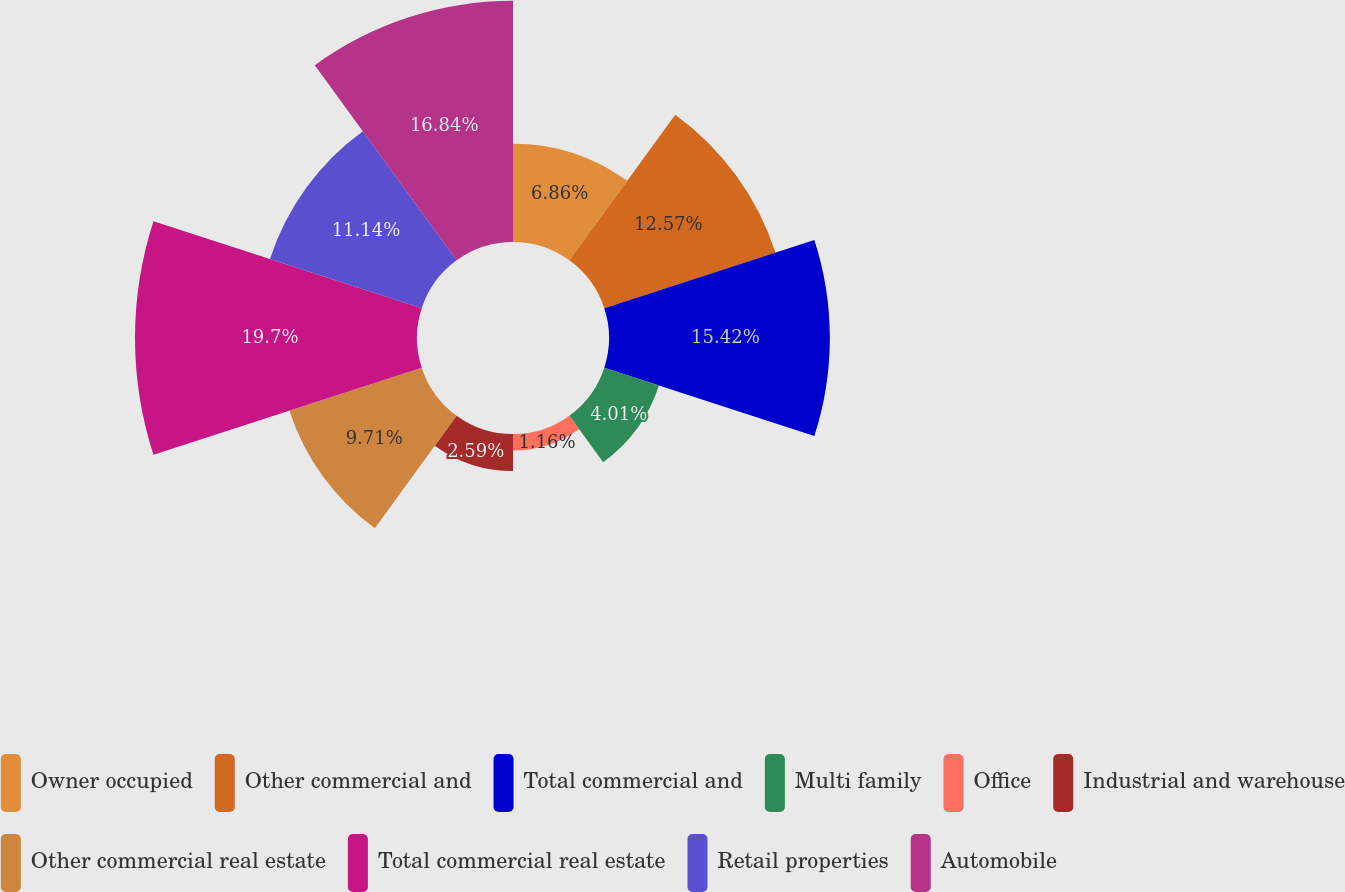Convert chart to OTSL. <chart><loc_0><loc_0><loc_500><loc_500><pie_chart><fcel>Owner occupied<fcel>Other commercial and<fcel>Total commercial and<fcel>Multi family<fcel>Office<fcel>Industrial and warehouse<fcel>Other commercial real estate<fcel>Total commercial real estate<fcel>Retail properties<fcel>Automobile<nl><fcel>6.86%<fcel>12.57%<fcel>15.42%<fcel>4.01%<fcel>1.16%<fcel>2.59%<fcel>9.71%<fcel>19.69%<fcel>11.14%<fcel>16.84%<nl></chart> 